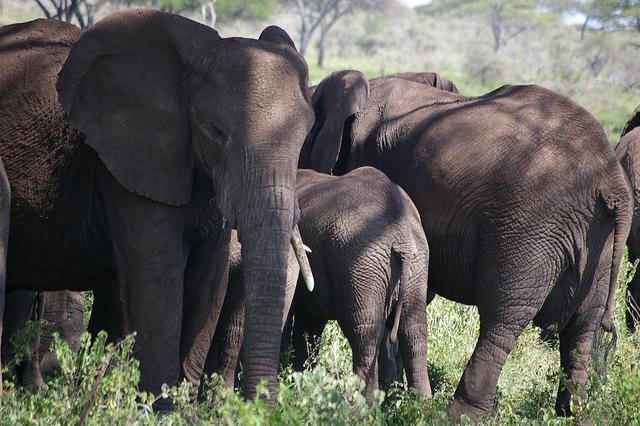Are there any baby elephants?
Give a very brief answer. Yes. How many animals?
Keep it brief. 4. How many animals are in the picture?
Give a very brief answer. 4. How many elephants are pictured?
Short answer required. 4. How many elephants are here?
Answer briefly. 4. How many elephants are in there?
Quick response, please. 3. What color are these animals?
Be succinct. Gray. Does this animal have tusks?
Write a very short answer. Yes. Is the elephant hiding from a predator?
Answer briefly. No. How many elephant that is standing do you see?
Keep it brief. 4. Are these Indian or African elephants?
Keep it brief. African. How many elephants are there?
Give a very brief answer. 4. Why is the elephant scratching its head against the tree?
Keep it brief. Itchy. Are the elephants all facing the same direction?
Be succinct. No. How big are these animals?
Be succinct. Very big. 